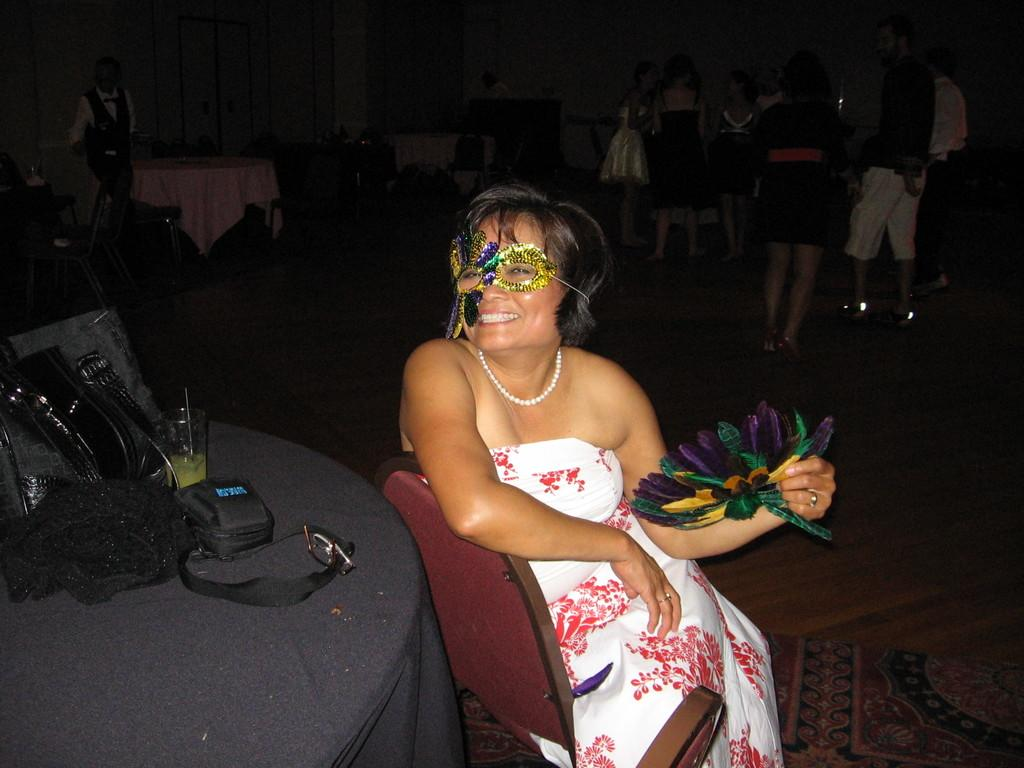What is the expression of the person in the image? The person in the image has a smile. What is the person wearing on their eyes? The person is wearing a mask on the eyes. Where are the other people located in the image? The people are standing on the right side of the image. What type of furniture can be seen in the image? There are tables and chairs in the image. What type of horse is present in the image? There is no horse present in the image. How does the crook use their tool in the image? There is no crook or tool present in the image. 